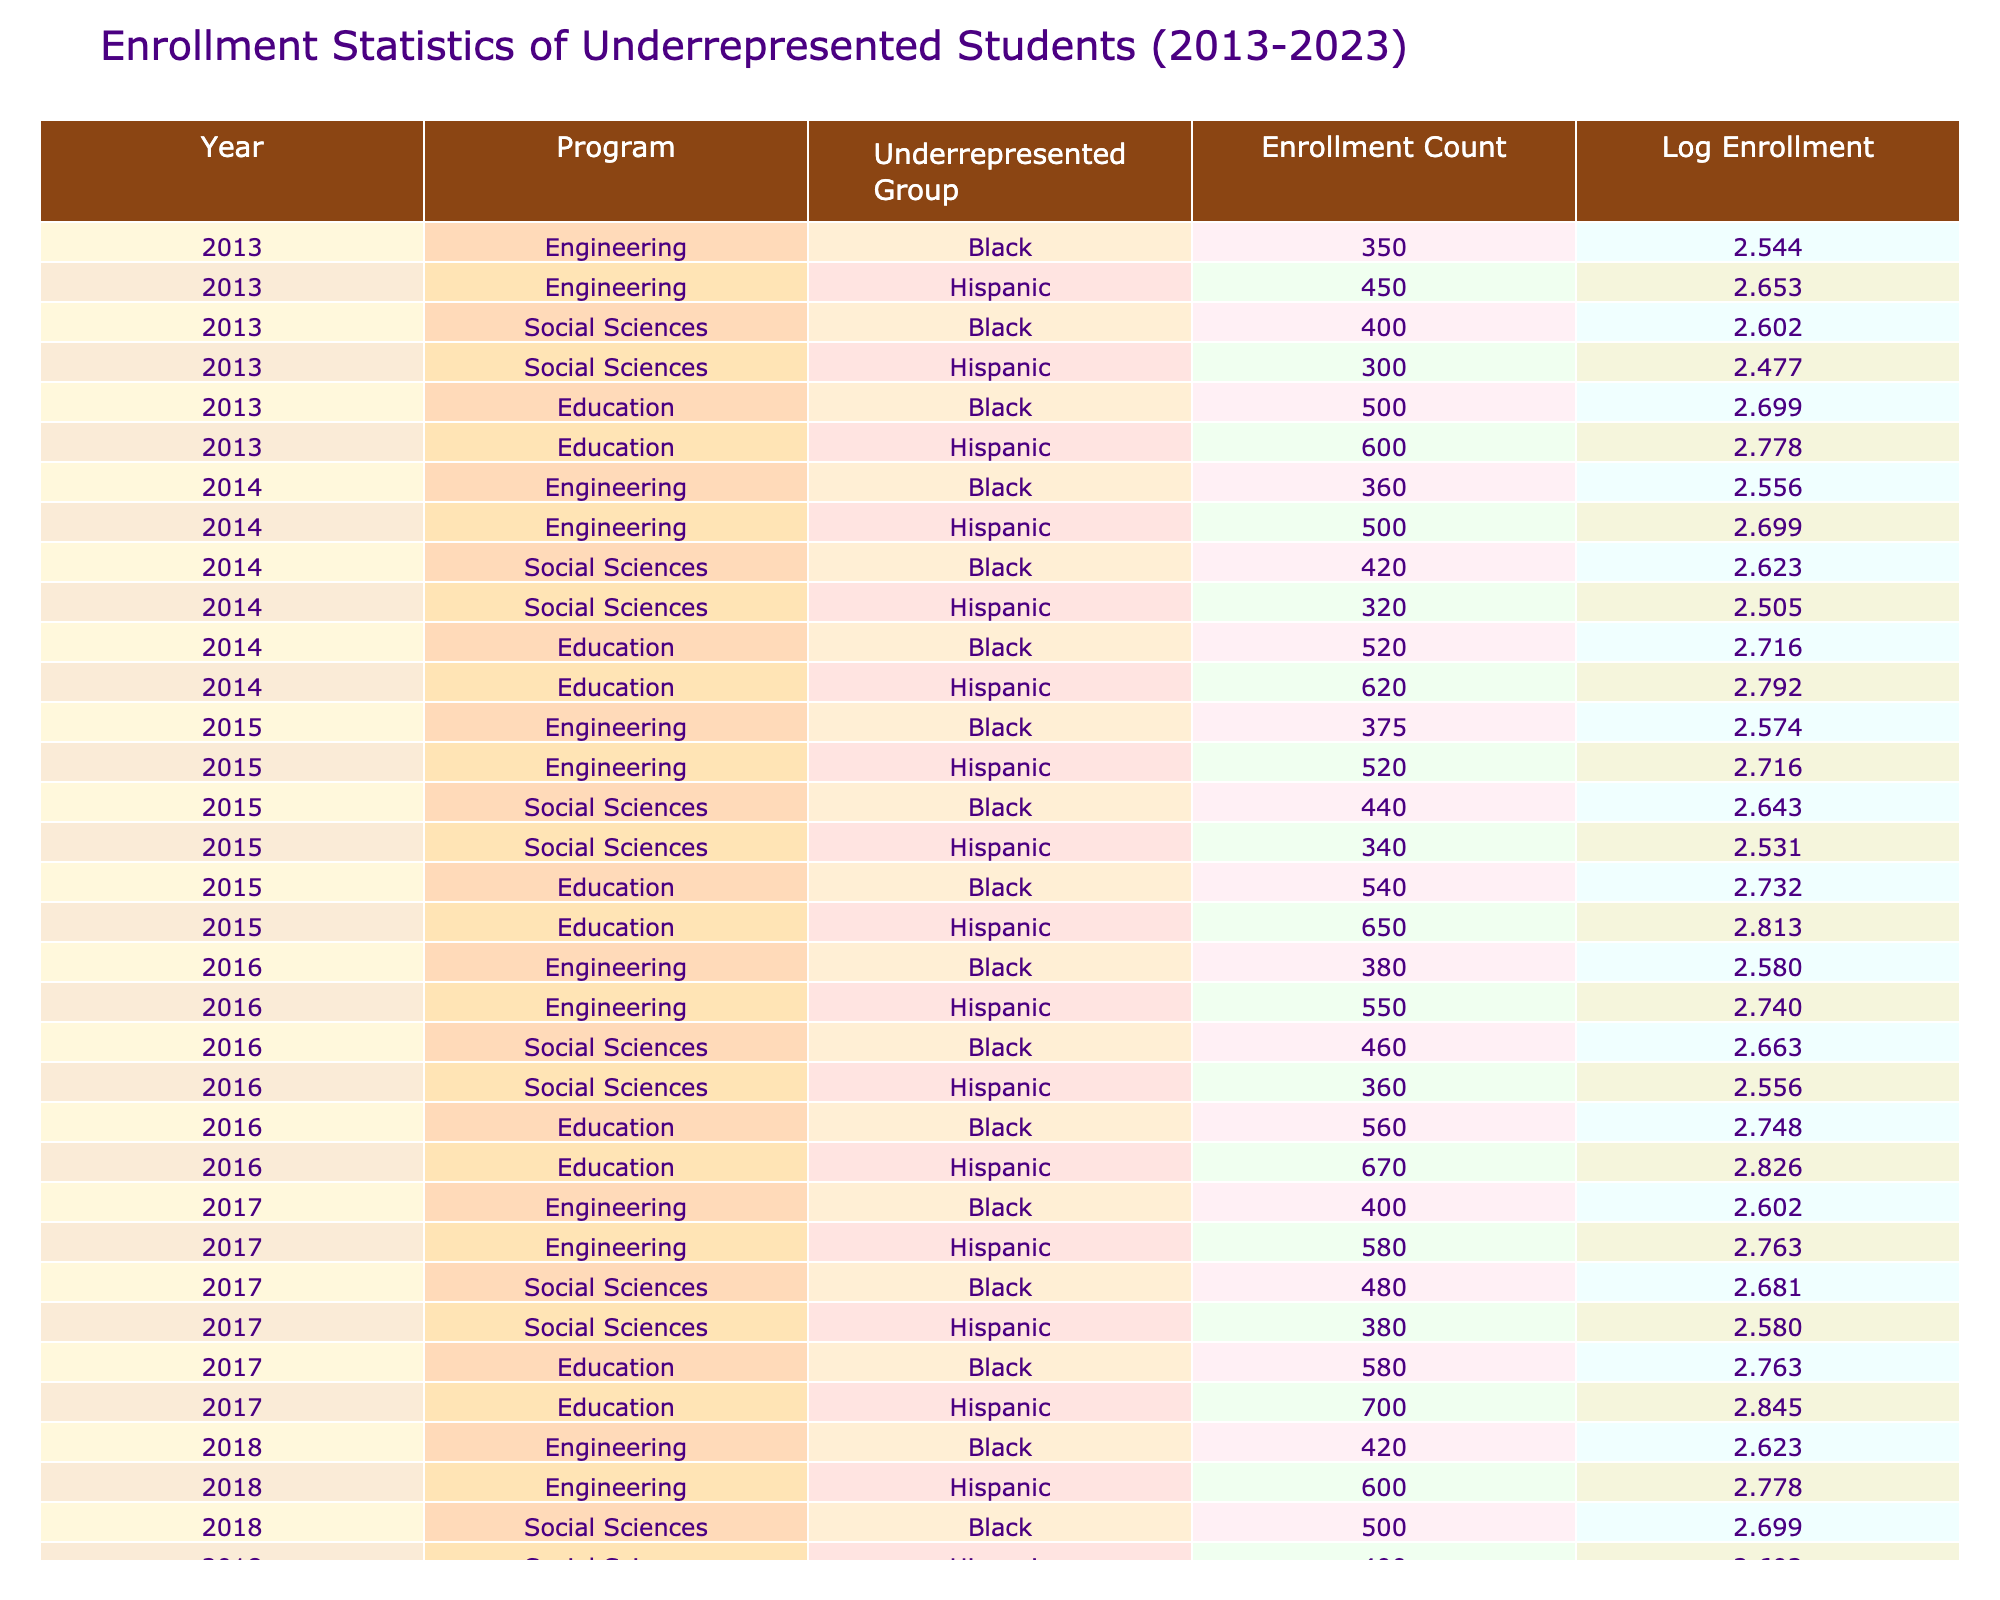What was the enrollment count of Hispanic students in Education in 2018? In 2018, looking at the table for the Education program under the Hispanic group, the enrollment count is clearly stated as 740.
Answer: 740 What was the total enrollment of Black students across all programs in 2022? To find the total enrollment of Black students in 2022, we need to add the counts for each program: Engineering (500) + Social Sciences (580) + Education (680) = 1860.
Answer: 1860 Was the enrollment count of Hispanic students in Engineering higher in 2023 compared to 2022? In 2022, the enrollment count for Hispanic students in Engineering was 680, while in 2023 it increased to 700. Since 700 is greater than 680, the statement is true.
Answer: Yes Which program had the highest enrollment count of Black students in 2020? Checking the table for 2020 under Black students shows Engineering (460), Social Sciences (540), and Education (640). Education has the highest enrollment count for Black students that year with 640.
Answer: Education What is the average enrollment count of Hispanic students in Education over the past decade (2013-2023)? The enrollment counts for Hispanic students in Education from 2013 to 2023 are: 600, 620, 650, 670, 700, 740, 780, 820, 860, 900. Summing these gives 7640 and dividing by 10 (the number of years), we find the average to be 764.
Answer: 764 What was the percentage increase in enrollment for Black students in Social Sciences from 2013 to 2023? The enrollment count for Black students in Social Sciences in 2013 was 400, and in 2023 it was 600. The increase is 600 - 400 = 200. The percentage increase is (200 / 400) * 100% = 50%.
Answer: 50% Did any program consistently show an increase in enrollment for the Black student group every year from 2013 to 2023? Analyzing the data, we see that the enrollment counts for Black students in Education increased each year: 500, 520, 540, 560, 580, 600, 620, 640, 680, 700. Therefore, the answer is yes.
Answer: Yes What was the enrollment trend for Hispanic students in Social Sciences from 2013 to 2023? Looking at the values for Hispanic students in Social Sciences: 300, 320, 340, 360, 380, 400, 420, 440, 480, the numbers show a steady increase each year, demonstrating a positive trend.
Answer: Steady increase 